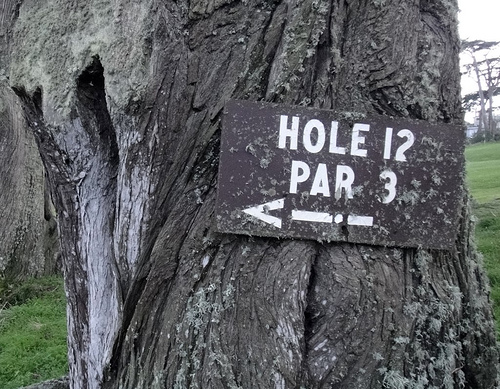<image>
Is the board behind the tree? No. The board is not behind the tree. From this viewpoint, the board appears to be positioned elsewhere in the scene. 